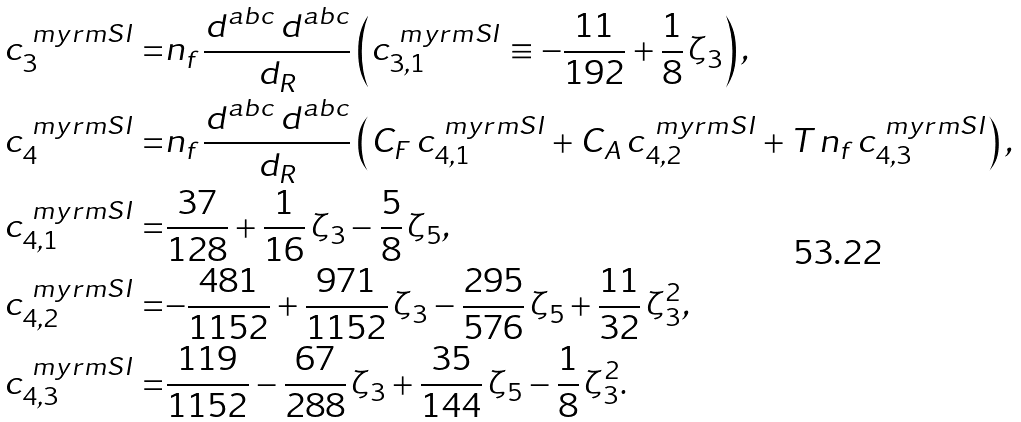<formula> <loc_0><loc_0><loc_500><loc_500>c _ { 3 } ^ { \ m y r m S I } = & n _ { f } \, \frac { d ^ { a b c } \, d ^ { a b c } } { d _ { R } } \left ( c _ { 3 , 1 } ^ { \ m y r m S I } \equiv - \frac { 1 1 } { 1 9 2 } + \frac { 1 } { 8 } \, \zeta _ { 3 } \right ) , \\ c _ { 4 } ^ { \ m y r m S I } = & n _ { f } \, \frac { d ^ { a b c } \, d ^ { a b c } } { d _ { R } } \left ( C _ { F } \, c _ { 4 , 1 } ^ { \ m y r m S I } + C _ { A } \, c _ { 4 , 2 } ^ { \ m y r m S I } + T \, n _ { f } \, c _ { 4 , 3 } ^ { \ m y r m S I } \right ) , \\ c _ { 4 , 1 } ^ { \ m y r m S I } = & { \frac { 3 7 } { 1 2 8 } + \frac { 1 } { 1 6 } \, \zeta _ { 3 } - \frac { 5 } { 8 } \, \zeta _ { 5 } } , \\ c _ { 4 , 2 } ^ { \ m y r m S I } = & { - \frac { 4 8 1 } { 1 1 5 2 } + \frac { 9 7 1 } { 1 1 5 2 } \, \zeta _ { 3 } - \frac { 2 9 5 } { 5 7 6 } \, \zeta _ { 5 } + \frac { 1 1 } { 3 2 } \, \zeta _ { 3 } ^ { 2 } } , \\ c _ { 4 , 3 } ^ { \ m y r m S I } = & { \frac { 1 1 9 } { 1 1 5 2 } - \frac { 6 7 } { 2 8 8 } \, \zeta _ { 3 } + \frac { 3 5 } { 1 4 4 } \, \zeta _ { 5 } - \frac { 1 } { 8 } \, \zeta _ { 3 } ^ { 2 } } .</formula> 